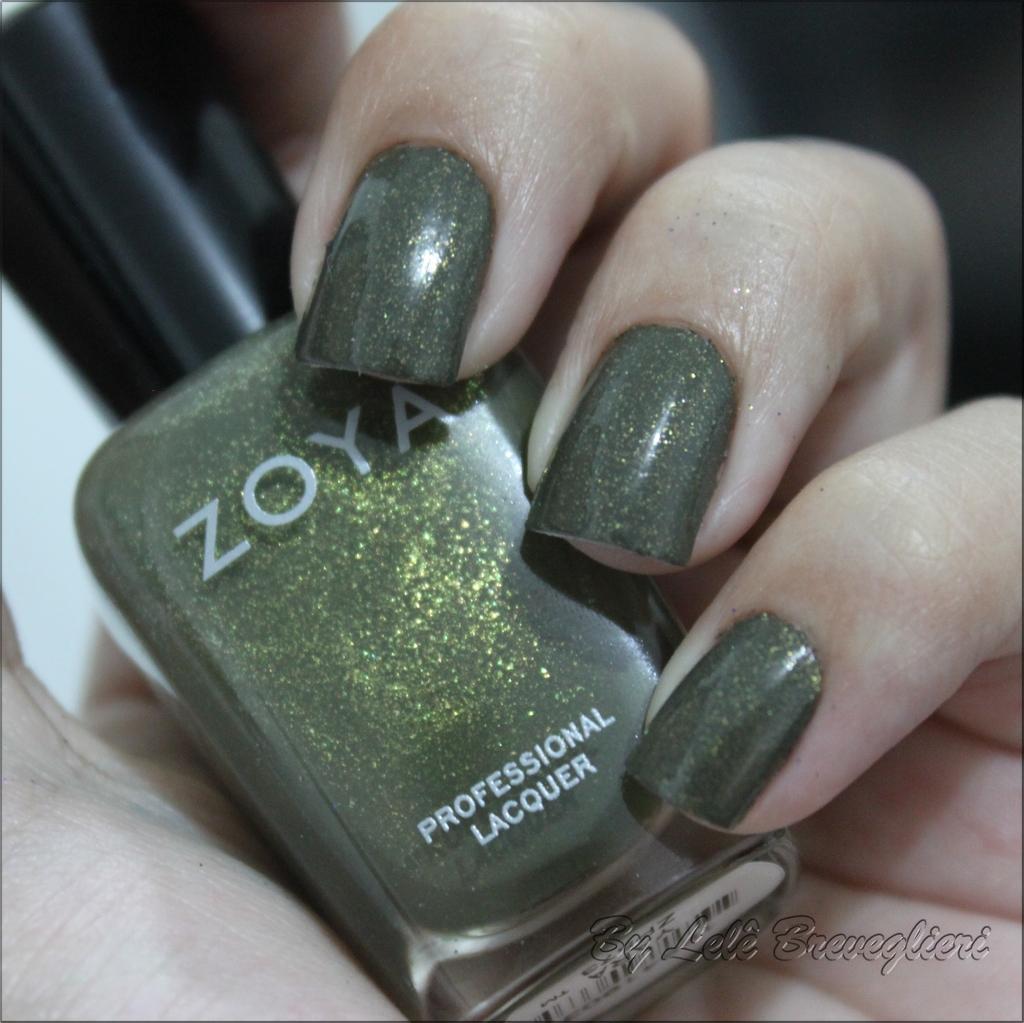Can you describe this image briefly? This image consists of a hand. In which we can see a nail polish bottle. It looks like a woman's hand. 